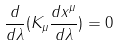Convert formula to latex. <formula><loc_0><loc_0><loc_500><loc_500>\frac { d } { d \lambda } ( K _ { \mu } \frac { d x ^ { \mu } } { d \lambda } ) = 0</formula> 